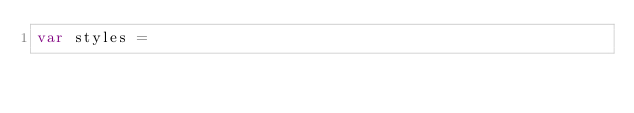Convert code to text. <code><loc_0><loc_0><loc_500><loc_500><_JavaScript_>var styles =</code> 